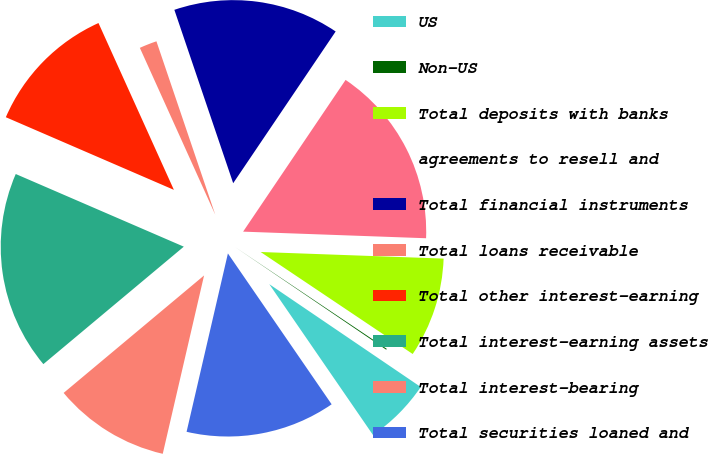Convert chart. <chart><loc_0><loc_0><loc_500><loc_500><pie_chart><fcel>US<fcel>Non-US<fcel>Total deposits with banks<fcel>agreements to resell and<fcel>Total financial instruments<fcel>Total loans receivable<fcel>Total other interest-earning<fcel>Total interest-earning assets<fcel>Total interest-bearing<fcel>Total securities loaned and<nl><fcel>5.92%<fcel>0.09%<fcel>8.83%<fcel>16.12%<fcel>14.66%<fcel>1.55%<fcel>11.75%<fcel>17.58%<fcel>10.29%<fcel>13.21%<nl></chart> 